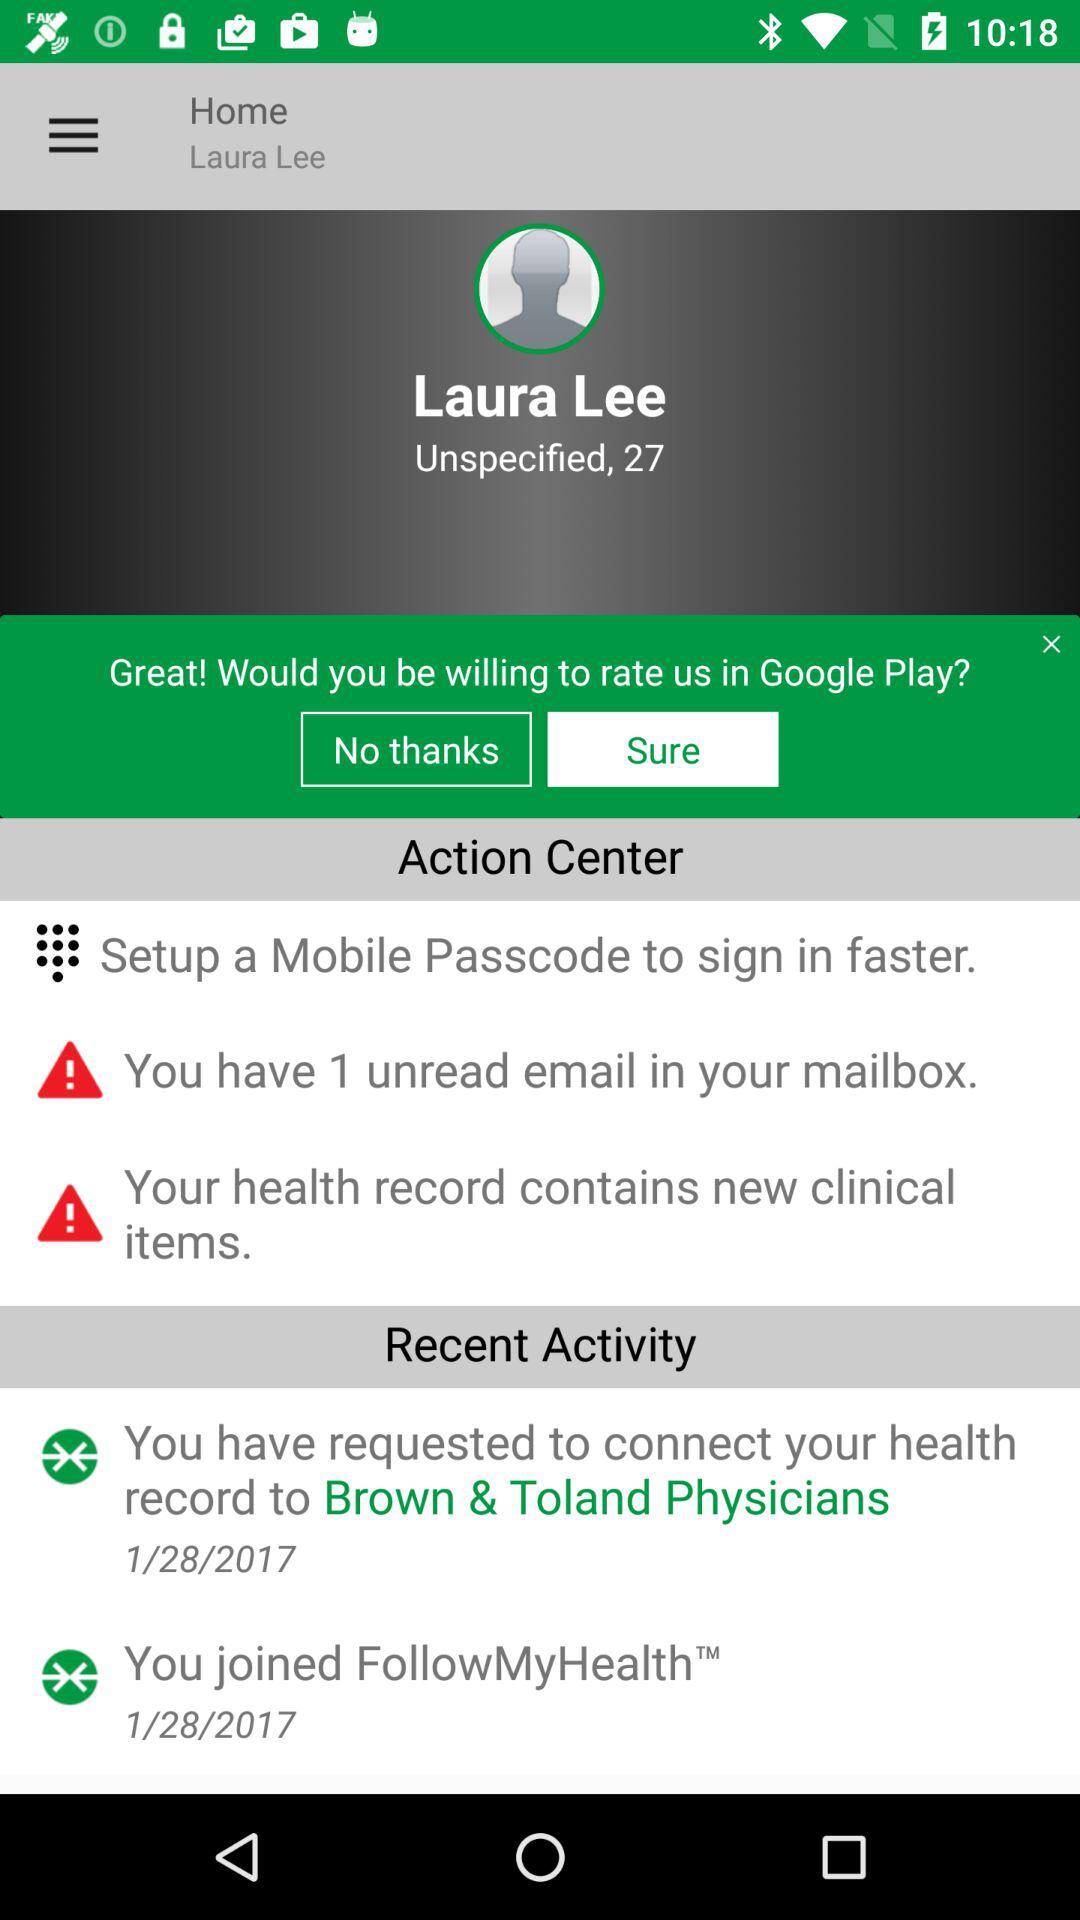How many unread emails does the user have?
Answer the question using a single word or phrase. 1 